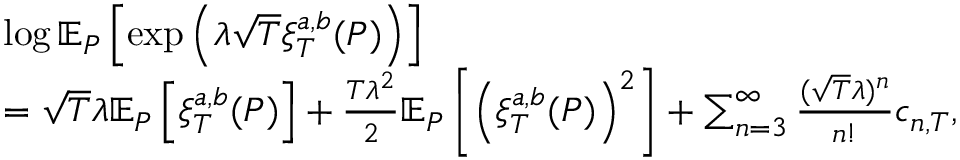<formula> <loc_0><loc_0><loc_500><loc_500>\begin{array} { r l } & { \log \mathbb { E } _ { P } \left [ \exp \left ( \lambda \sqrt { T } \xi _ { T } ^ { a , b } ( P ) \right ) \right ] } \\ & { = \sqrt { T } \lambda \mathbb { E } _ { P } \left [ \xi _ { T } ^ { a , b } ( P ) \right ] + \frac { T \lambda ^ { 2 } } { 2 } \mathbb { E } _ { P } \left [ \left ( \xi _ { T } ^ { a , b } ( P ) \right ) ^ { 2 } \right ] + \sum _ { n = 3 } ^ { \infty } \frac { ( \sqrt { T } \lambda ) ^ { n } } { n ! } c _ { n , T } , } \end{array}</formula> 